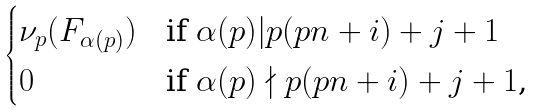Convert formula to latex. <formula><loc_0><loc_0><loc_500><loc_500>\begin{cases} \nu _ { p } ( F _ { \alpha ( p ) } ) & \text {if $\alpha(p) | p (p n + i) + j + 1$} \\ 0 & \text {if $\alpha(p) \nmid p (p n + i) + j + 1$,} \end{cases}</formula> 